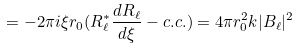Convert formula to latex. <formula><loc_0><loc_0><loc_500><loc_500>= - 2 \pi i \xi r _ { 0 } ( R _ { \ell } ^ { \ast } \frac { d R _ { \ell } } { d \xi } - c . c . ) = 4 \pi r _ { 0 } ^ { 2 } k | B _ { \ell } | ^ { 2 }</formula> 